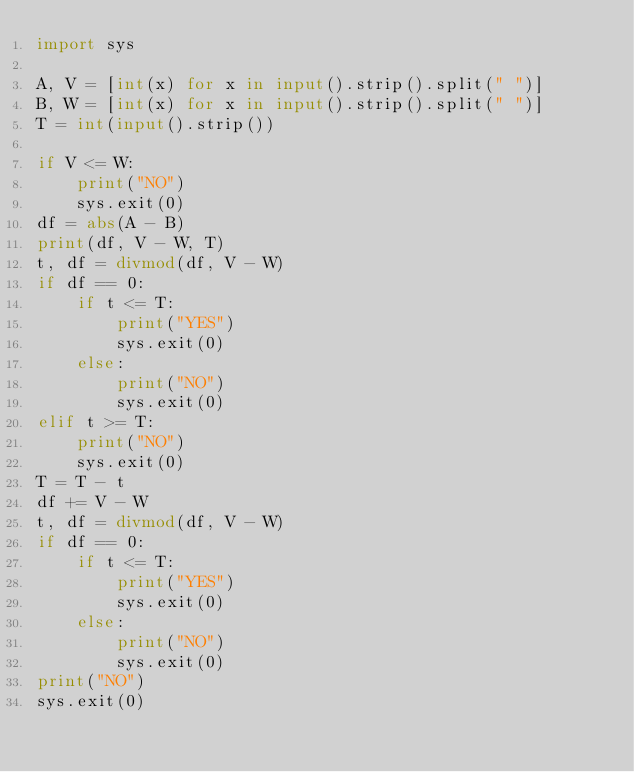Convert code to text. <code><loc_0><loc_0><loc_500><loc_500><_Python_>import sys
 
A, V = [int(x) for x in input().strip().split(" ")]
B, W = [int(x) for x in input().strip().split(" ")]
T = int(input().strip())
 
if V <= W:
    print("NO")
    sys.exit(0)
df = abs(A - B)
print(df, V - W, T)
t, df = divmod(df, V - W)
if df == 0:
    if t <= T:
        print("YES")
        sys.exit(0)
    else:
        print("NO")
        sys.exit(0)
elif t >= T:
    print("NO")
    sys.exit(0)
T = T - t
df += V - W
t, df = divmod(df, V - W)
if df == 0:
    if t <= T:
        print("YES")
        sys.exit(0)
    else:
        print("NO")
        sys.exit(0)
print("NO")
sys.exit(0)</code> 